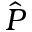Convert formula to latex. <formula><loc_0><loc_0><loc_500><loc_500>\hat { P }</formula> 